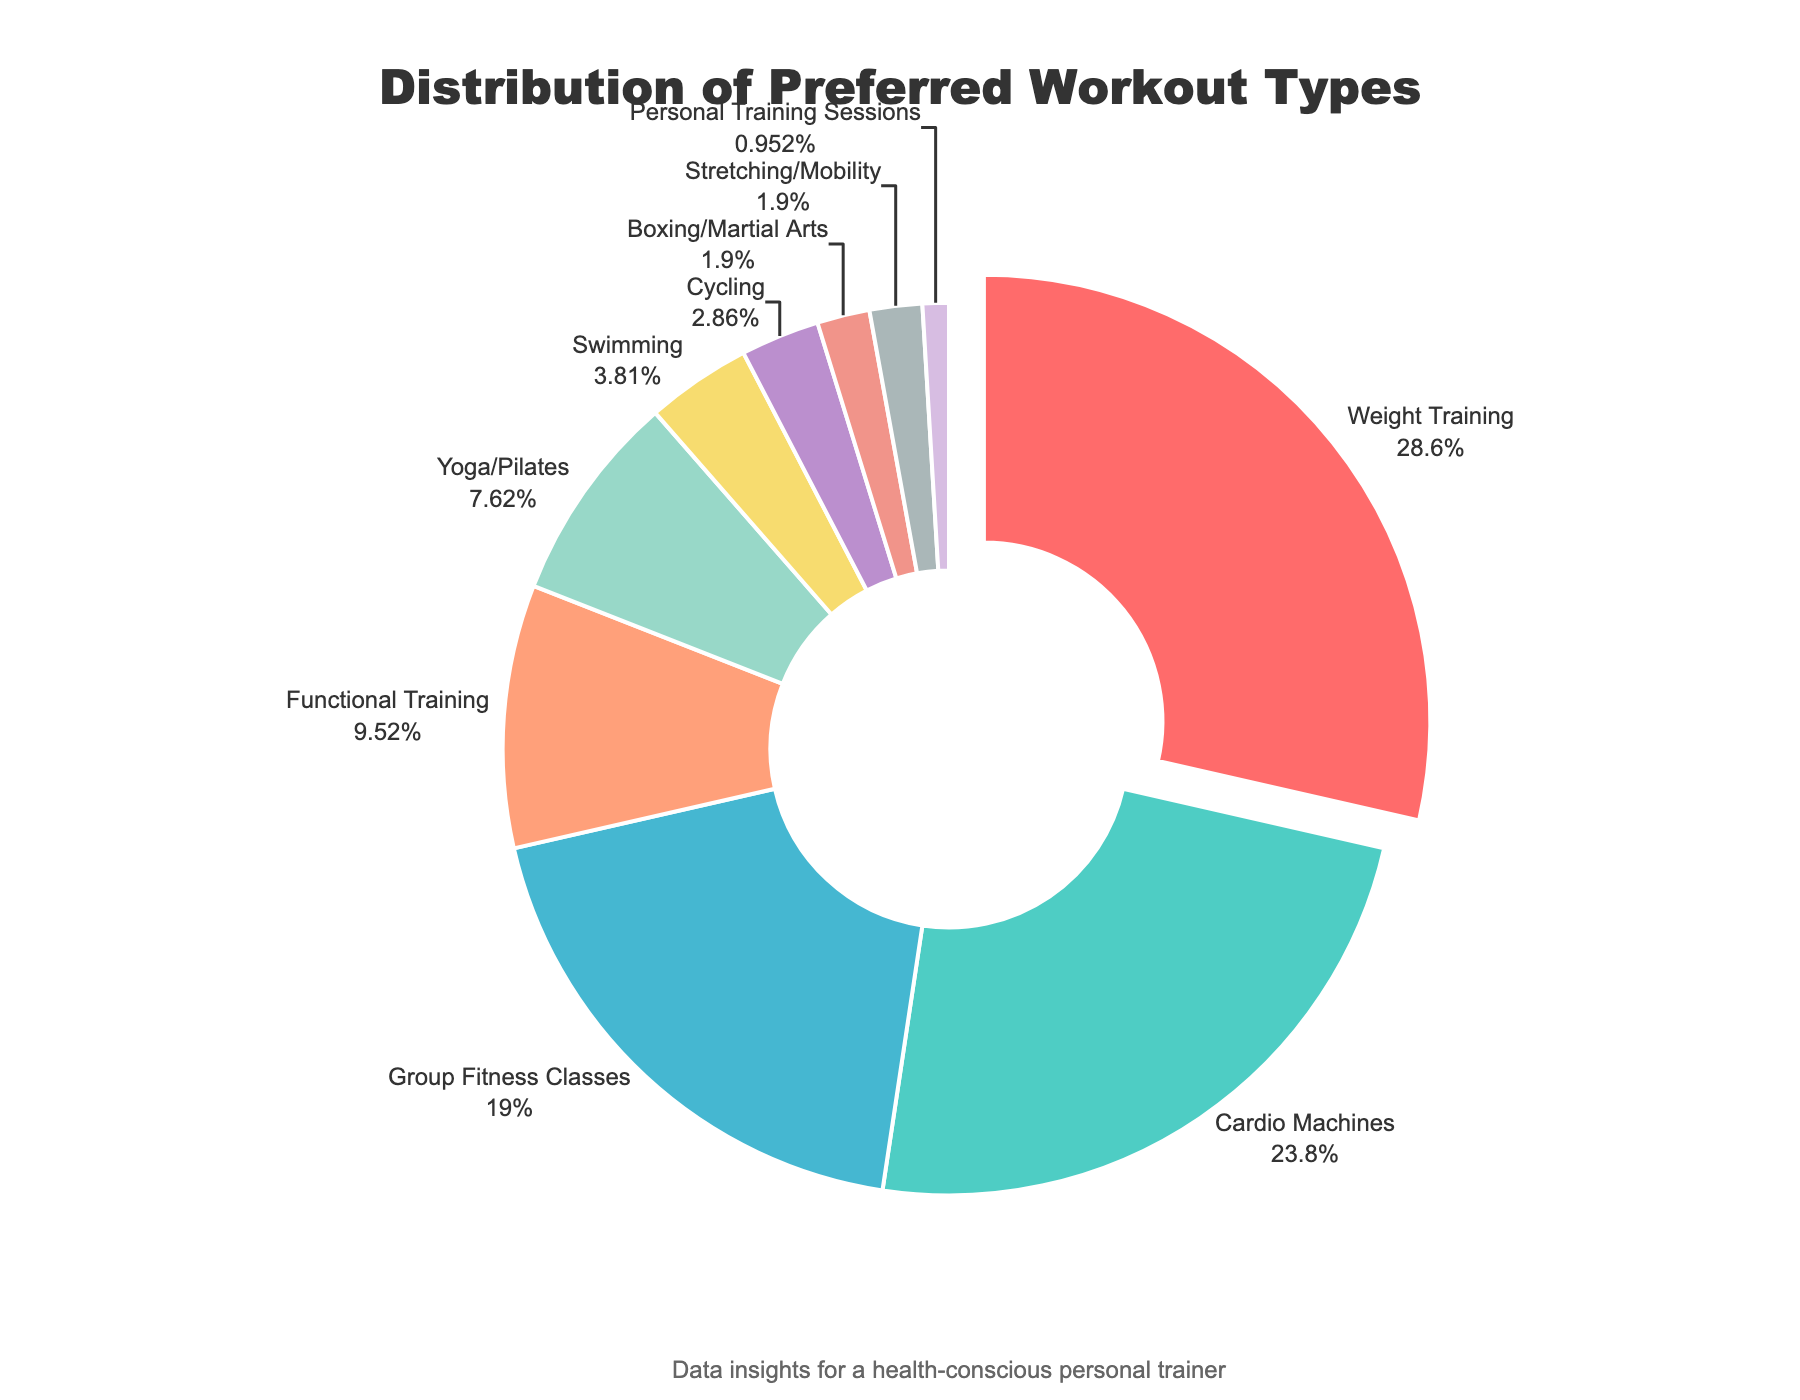Which workout type is the most preferred among gym members? The segment of the chart pulled slightly outward indicates the most preferred workout type. It shows "Weight Training" at 30%. Weight Training
Answer: 30% Which workout types have the smallest and equal preferences? By looking at the smallest and equally sized segments, we can see that "Boxing/Martial Arts" and "Stretching/Mobility" both occupy small 2% slices. Boxing/Martial Arts and Stretching/Mobility
Answer: 2% What is the combined percentage of members who prefer Group Fitness Classes and Functional Training? Add 20% (Group Fitness Classes) and 10% (Functional Training) to get the combined percentage. 20% + 10% = 30%
Answer: 30% Which workout type has a preference percentage that is twice as much as Yoga/Pilates? Yoga/Pilates has 8%, double that is 16%. The workout closest is Group Fitness Classes at 20%. Group Fitness Classes
Answer: 20% Is the preference for Cardio Machines greater than Yoga/Pilates? By comparing the segments, Cardio Machines have 25% while Yoga/Pilates have 8%. Yes, 25% is greater than 8%. Yes
Answer: Cardio Machines Which color segment represents Functional Training, and what is its percentage? The colors help distinguish the segments. According to the chart, Functional Training is represented by the color blue and is 10%. Blue, 10%
Answer: Blue, 10% What percentage of gym members prefer workout types related to strength training (Weight Training and Functional Training)? Add the percentages for Weight Training (30%) and Functional Training (10%) for a total strength training percentage. 30% + 10% = 40%
Answer: 40% If we combine the preferences for swimming, cycling, boxing/martial arts, stretching/mobility, and personal training, what total percentage do we get? Sum the percentages: 4% (Swimming) + 3% (Cycling) + 2% (Boxing/Martial Arts) + 2% (Stretching/Mobility) + 1% (Personal Training). 4% + 3% + 2% + 2% + 1% = 12%
Answer: 12% How does the preference for Group Fitness Classes compare to that for Cardio Machines? Compare the segments visually, Group Fitness Classes is 20% and Cardio Machines is 25%. Cardio Machines has a higher preference. Cardio Machines is higher
Answer: Cardio Machines is higher Which workout type has a higher preference, Yoga/Pilates or Functional Training? By comparing segments, Yoga/Pilates is at 8% while Functional Training is at 10%. Functional Training is higher. Functional Training
Answer: Functional Training 